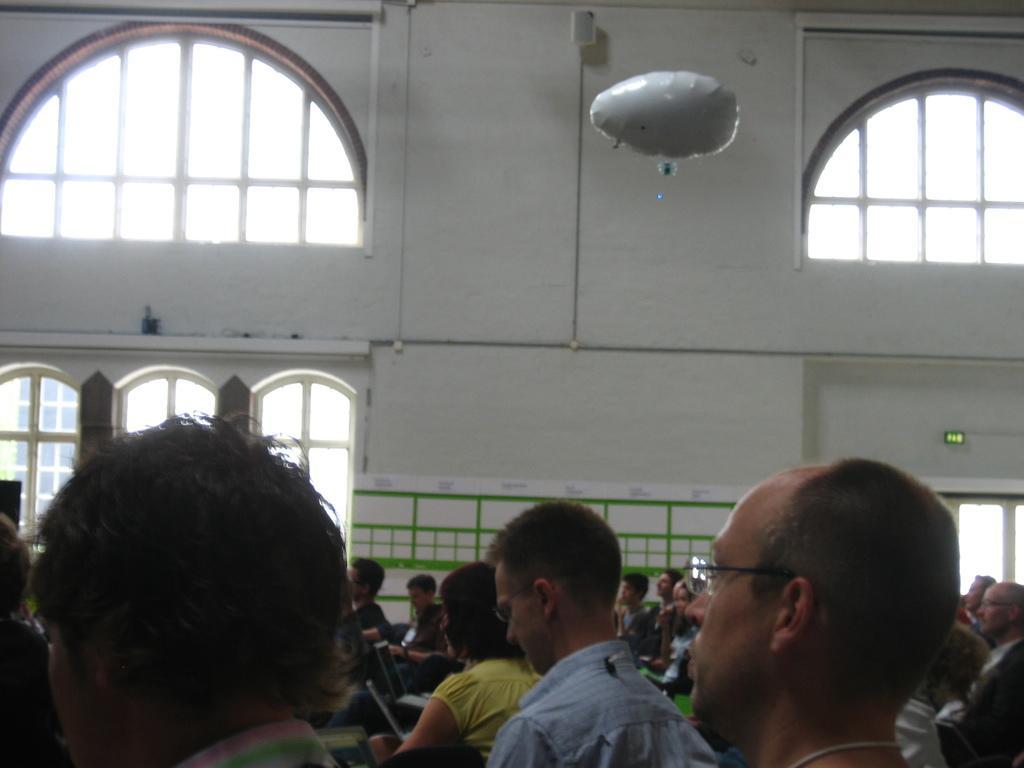In one or two sentences, can you explain what this image depicts? In this image I can see number of people and on the bottom side I can see few laptops. On the top side of this image I can see a white colour thing and in the background I can see the wall, windows and a white colour board. 